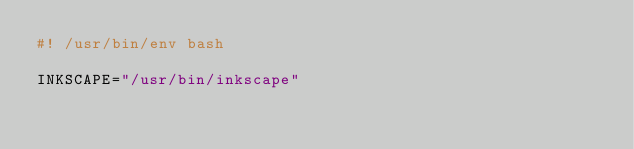Convert code to text. <code><loc_0><loc_0><loc_500><loc_500><_Bash_>#! /usr/bin/env bash

INKSCAPE="/usr/bin/inkscape"</code> 